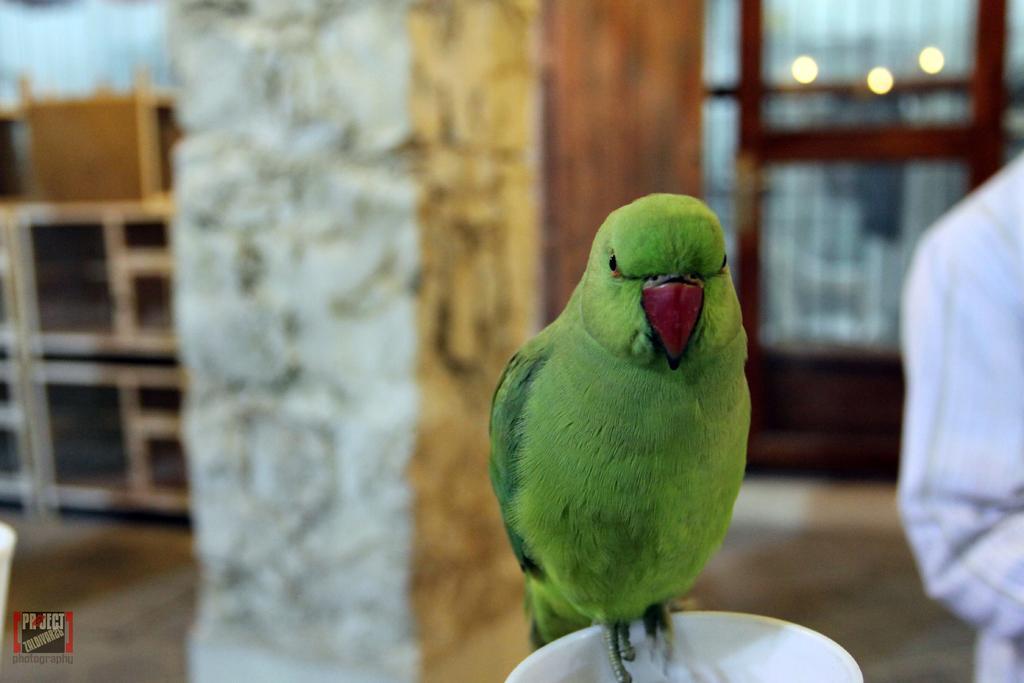Can you describe this image briefly? In this image, I can see a parrot standing on an object. On the right side of the image, there is a person standing. In the background, I can see few objects, which are slightly blurred. At the bottom left corner of the image, I can see the watermark. 